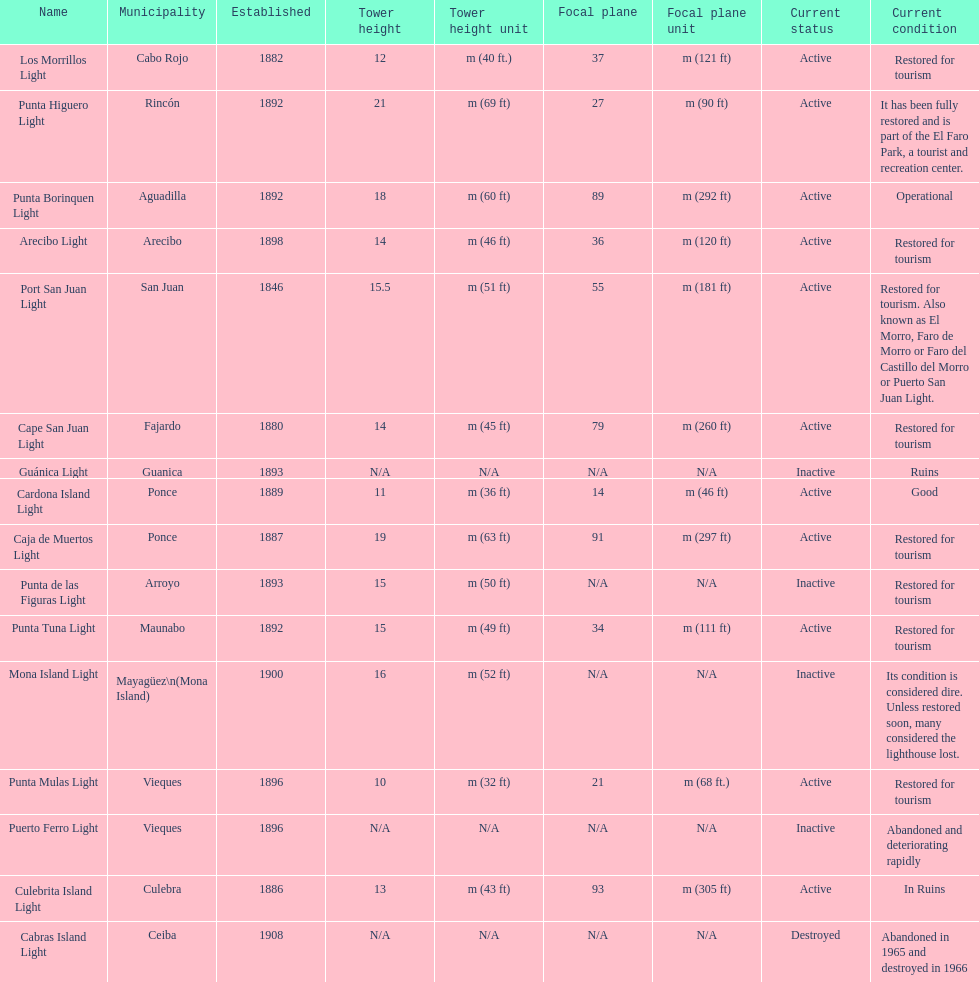Were any towers established before the year 1800? No. 